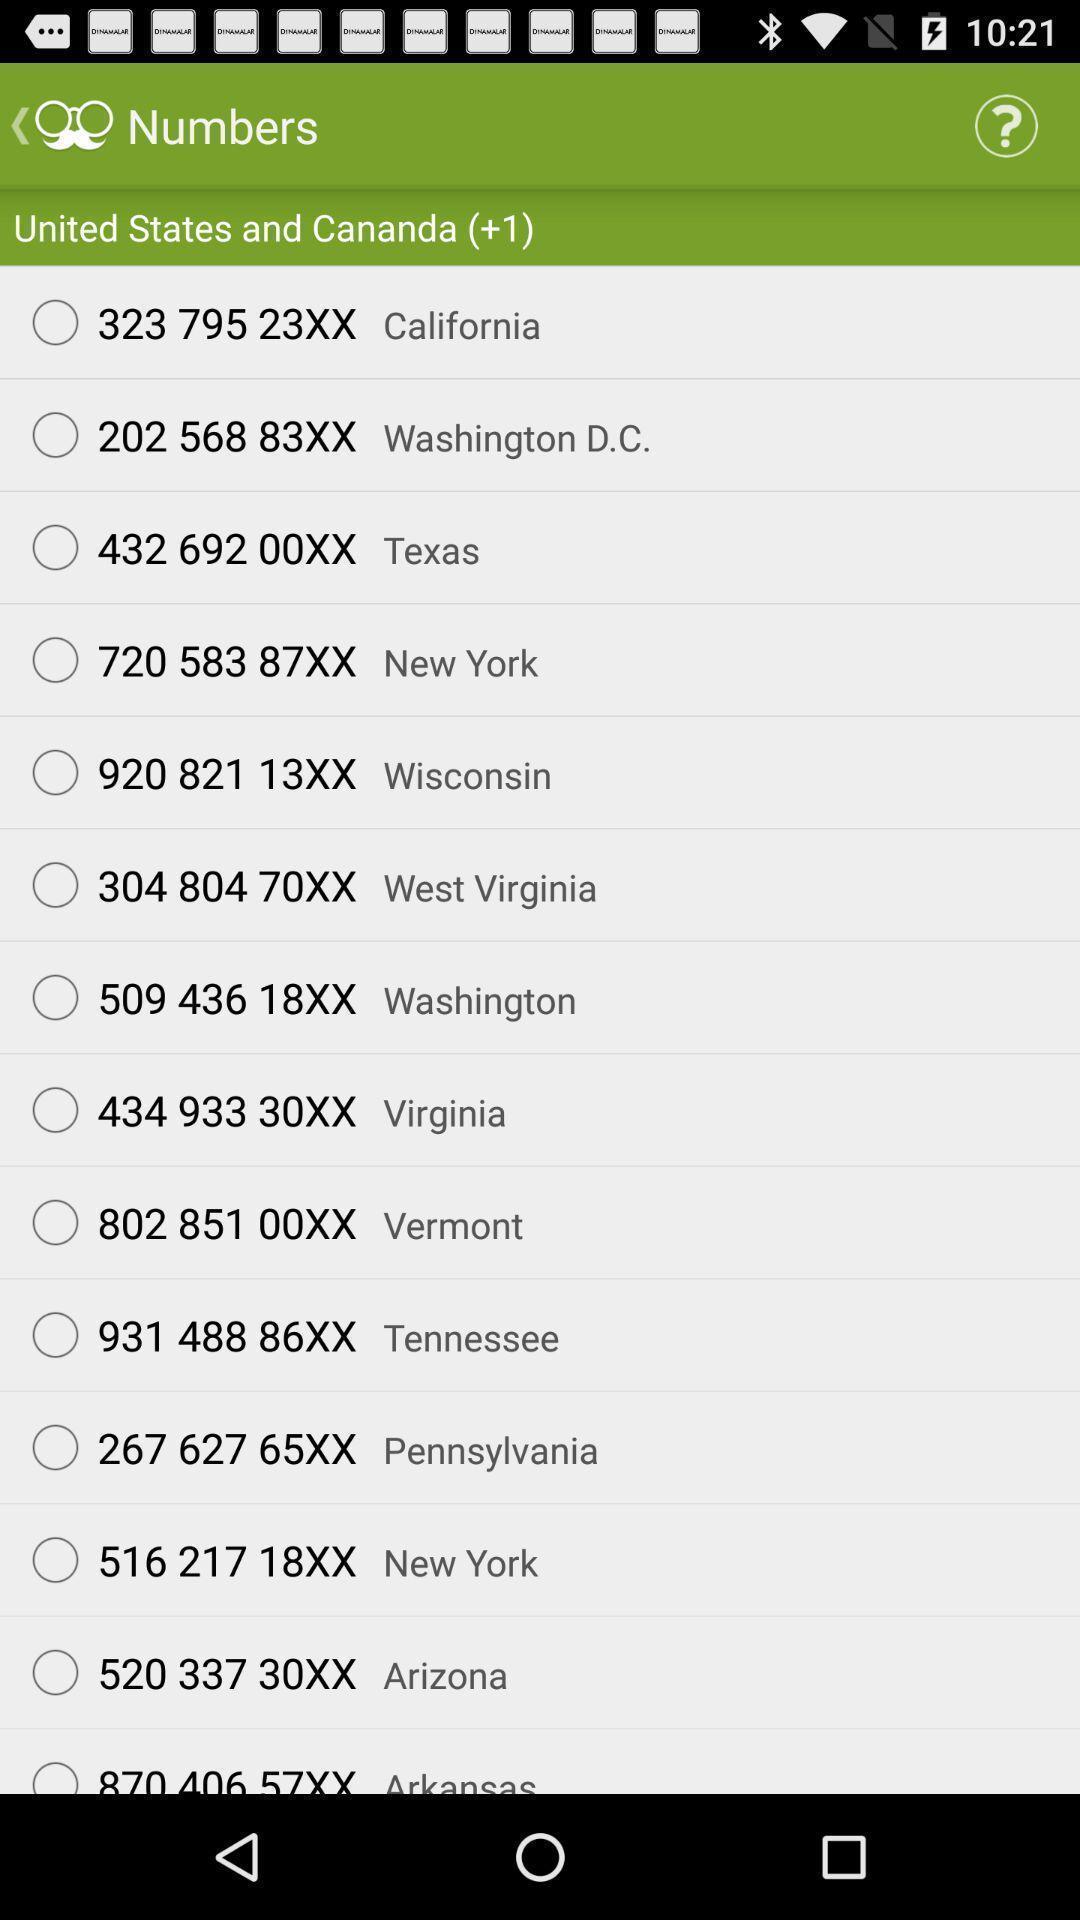Explain what's happening in this screen capture. Screen displaying list of contact numbers. 